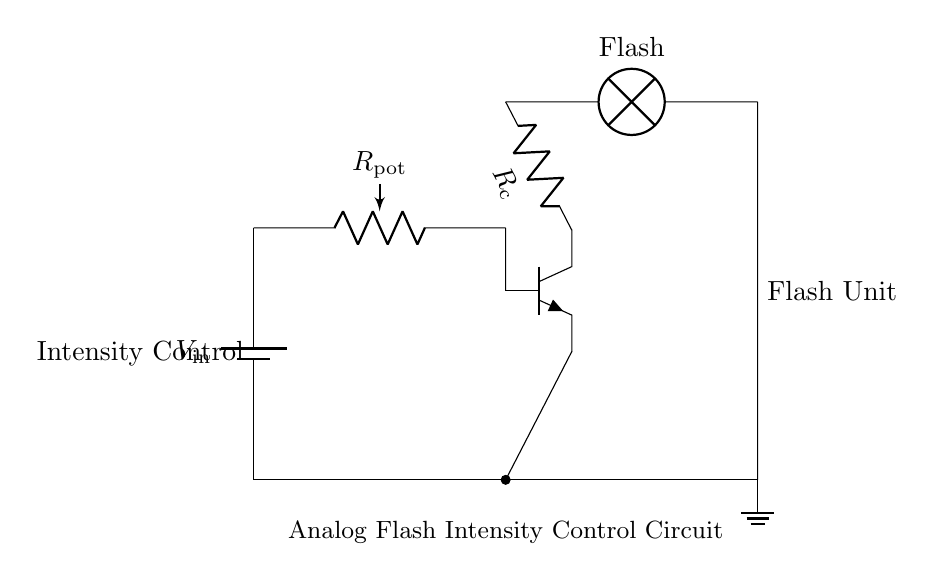What component is used for intensity control? The circuit features a potentiometer labeled as R_pot, which is designed to adjust the intensity of the flash by varying the resistance in the circuit.
Answer: R_pot What type of transistor is used in this circuit? The circuit includes an NPN transistor indicated by the label at the transistor symbol (Q), which provides amplification and control of the current flowing to the flash unit.
Answer: NPN What is the role of the resistor in this circuit? The resistor labeled as R_c in the circuit serves to limit the current flowing through the flash unit, protecting it from excessive current that could cause damage or failure.
Answer: Limit current How does the potentiometer affect the flash intensity? The potentiometer alters the resistance in the circuit, which changes the voltage and current through the transistor, thereby controlling how brightly the flash unit lights up.
Answer: Adjusts voltage Where is the flash unit located in the circuit? The flash unit is positioned to the right of the transistor in the circuit, directly connected to it and represented by a lamp symbol, indicating its function.
Answer: Right side What is connected at the bottom of the circuit? The bottom of the circuit is connected to a ground node, which serves as a common reference point for all components in the circuit, ensuring stable operation.
Answer: Ground What happens if the potentiometer is turned to maximum resistance? When the potentiometer is set to maximum resistance, the current flowing to the flash unit decreases significantly, resulting in a dimmer flash output.
Answer: Flash dims 